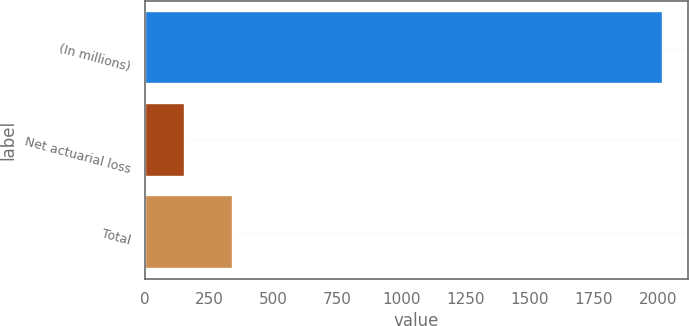Convert chart. <chart><loc_0><loc_0><loc_500><loc_500><bar_chart><fcel>(In millions)<fcel>Net actuarial loss<fcel>Total<nl><fcel>2017<fcel>157<fcel>343<nl></chart> 